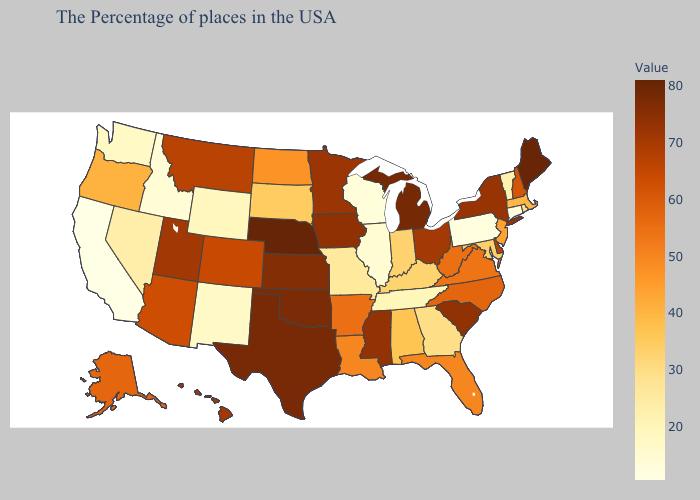Does Wyoming have the highest value in the USA?
Write a very short answer. No. Does Vermont have the lowest value in the USA?
Answer briefly. No. Does Arkansas have the highest value in the USA?
Concise answer only. No. Which states have the lowest value in the USA?
Quick response, please. California. Does Washington have the lowest value in the USA?
Answer briefly. No. Which states hav the highest value in the Northeast?
Concise answer only. Maine. Among the states that border Michigan , does Wisconsin have the lowest value?
Short answer required. Yes. 